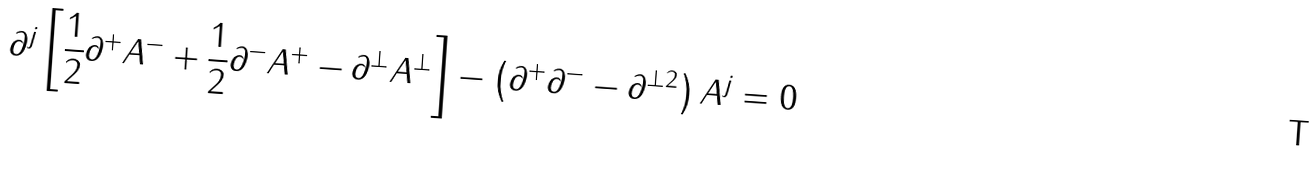<formula> <loc_0><loc_0><loc_500><loc_500>\partial ^ { j } \left [ \frac { 1 } { 2 } \partial ^ { + } A ^ { - } + \frac { 1 } { 2 } \partial ^ { - } A ^ { + } - \partial ^ { \perp } A ^ { \perp } \right ] - \left ( \partial ^ { + } \partial ^ { - } - \partial ^ { \perp 2 } \right ) A ^ { j } = 0</formula> 